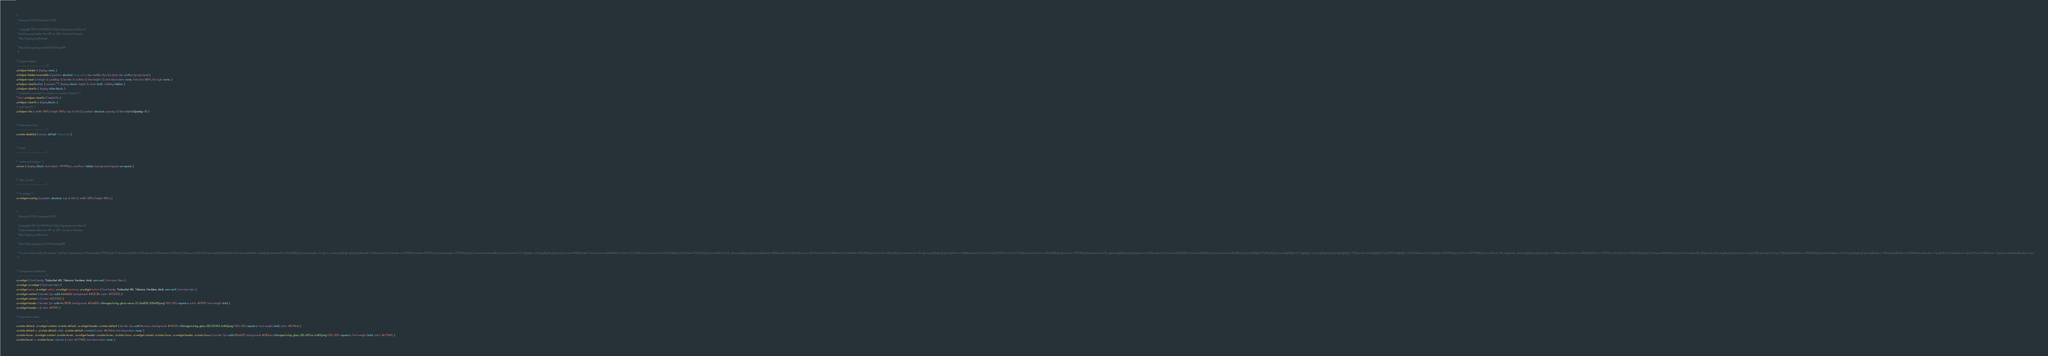Convert code to text. <code><loc_0><loc_0><loc_500><loc_500><_CSS_>/*
 * jQuery UI CSS Framework 1.8.13
 *
 * Copyright 2011, AUTHORS.txt (http://jqueryui.com/about)
 * Dual licensed under the MIT or GPL Version 2 licenses.
 * http://jquery.org/license
 *
 * http://docs.jquery.com/UI/Theming/API
 */

/* Layout helpers
----------------------------------*/
.ui-helper-hidden { display: none; }
.ui-helper-hidden-accessible { position: absolute !important; clip: rect(1px 1px 1px 1px); clip: rect(1px,1px,1px,1px); }
.ui-helper-reset { margin: 0; padding: 0; border: 0; outline: 0; line-height: 1.3; text-decoration: none; font-size: 100%; list-style: none; }
.ui-helper-clearfix:after { content: "."; display: block; height: 0; clear: both; visibility: hidden; }
.ui-helper-clearfix { display: inline-block; }
/* required comment for clearfix to work in Opera \*/
* html .ui-helper-clearfix { height:1%; }
.ui-helper-clearfix { display:block; }
/* end clearfix */
.ui-helper-zfix { width: 100%; height: 100%; top: 0; left: 0; position: absolute; opacity: 0; filter:Alpha(Opacity=0); }


/* Interaction Cues
----------------------------------*/
.ui-state-disabled { cursor: default !important; }


/* Icons
----------------------------------*/

/* states and images */
.ui-icon { display: block; text-indent: -99999px; overflow: hidden; background-repeat: no-repeat; }


/* Misc visuals
----------------------------------*/

/* Overlays */
.ui-widget-overlay { position: absolute; top: 0; left: 0; width: 100%; height: 100%; }


/*
 * jQuery UI CSS Framework 1.8.13
 *
 * Copyright 2011, AUTHORS.txt (http://jqueryui.com/about)
 * Dual licensed under the MIT or GPL Version 2 licenses.
 * http://jquery.org/license
 *
 * http://docs.jquery.com/UI/Theming/API
 *
 * To view and modify this theme, visit http://jqueryui.com/themeroller/?ffDefault=Trebuchet%20MS,%20Tahoma,%20Verdana,%20Arial,%20sans-serif&fwDefault=bold&fsDefault=1.1em&cornerRadius=4px&bgColorHeader=f6a828&bgTextureHeader=12_gloss_wave.png&bgImgOpacityHeader=35&borderColorHeader=e78f08&fcHeader=ffffff&iconColorHeader=ffffff&bgColorContent=eeeeee&bgTextureContent=03_highlight_soft.png&bgImgOpacityContent=100&borderColorContent=dddddd&fcContent=333333&iconColorContent=222222&bgColorDefault=f6f6f6&bgTextureDefault=02_glass.png&bgImgOpacityDefault=100&borderColorDefault=cccccc&fcDefault=1c94c4&iconColorDefault=ef8c08&bgColorHover=fdf5ce&bgTextureHover=02_glass.png&bgImgOpacityHover=100&borderColorHover=fbcb09&fcHover=c77405&iconColorHover=ef8c08&bgColorActive=ffffff&bgTextureActive=02_glass.png&bgImgOpacityActive=65&borderColorActive=fbd850&fcActive=eb8f00&iconColorActive=ef8c08&bgColorHighlight=ffe45c&bgTextureHighlight=03_highlight_soft.png&bgImgOpacityHighlight=75&borderColorHighlight=fed22f&fcHighlight=363636&iconColorHighlight=228ef1&bgColorError=b81900&bgTextureError=08_diagonals_thick.png&bgImgOpacityError=18&borderColorError=cd0a0a&fcError=ffffff&iconColorError=ffd27a&bgColorOverlay=666666&bgTextureOverlay=08_diagonals_thick.png&bgImgOpacityOverlay=20&opacityOverlay=50&bgColorShadow=000000&bgTextureShadow=01_flat.png&bgImgOpacityShadow=10&opacityShadow=20&thicknessShadow=5px&offsetTopShadow=-5px&offsetLeftShadow=-5px&cornerRadiusShadow=5px
 */


/* Component containers
----------------------------------*/
.ui-widget { font-family: Trebuchet MS, Tahoma, Verdana, Arial, sans-serif; font-size: 1.1em; }
.ui-widget .ui-widget { font-size: 1em; }
.ui-widget input, .ui-widget select, .ui-widget textarea, .ui-widget button { font-family: Trebuchet MS, Tahoma, Verdana, Arial, sans-serif; font-size: 1em; }
.ui-widget-content { border: 1px solid #dddddd; background: #2F2C2B; color: #333333; }
.ui-widget-content a { color: #333333; }
.ui-widget-header { border: 1px solid #e78f08; background: #f6a828 url(images/ui-bg_gloss-wave_35_f6a828_500x100.png) 50% 50% repeat-x; color: #ffffff; font-weight: bold; }
.ui-widget-header a { color: #ffffff; }

/* Interaction states
----------------------------------*/
.ui-state-default, .ui-widget-content .ui-state-default, .ui-widget-header .ui-state-default { border: 1px solid #cccccc; background: #f6f6f6 url(images/ui-bg_glass_100_f6f6f6_1x400.png) 50% 50% repeat-x; font-weight: bold; color: #1c94c4; }
.ui-state-default a, .ui-state-default a:link, .ui-state-default a:visited { color: #1c94c4; text-decoration: none; }
.ui-state-hover, .ui-widget-content .ui-state-hover, .ui-widget-header .ui-state-hover, .ui-state-focus, .ui-widget-content .ui-state-focus, .ui-widget-header .ui-state-focus { border: 1px solid #fbcb09; background: #fdf5ce url(images/ui-bg_glass_100_fdf5ce_1x400.png) 50% 50% repeat-x; font-weight: bold; color: #c77405; }
.ui-state-hover a, .ui-state-hover a:hover { color: #c77405; text-decoration: none; }</code> 